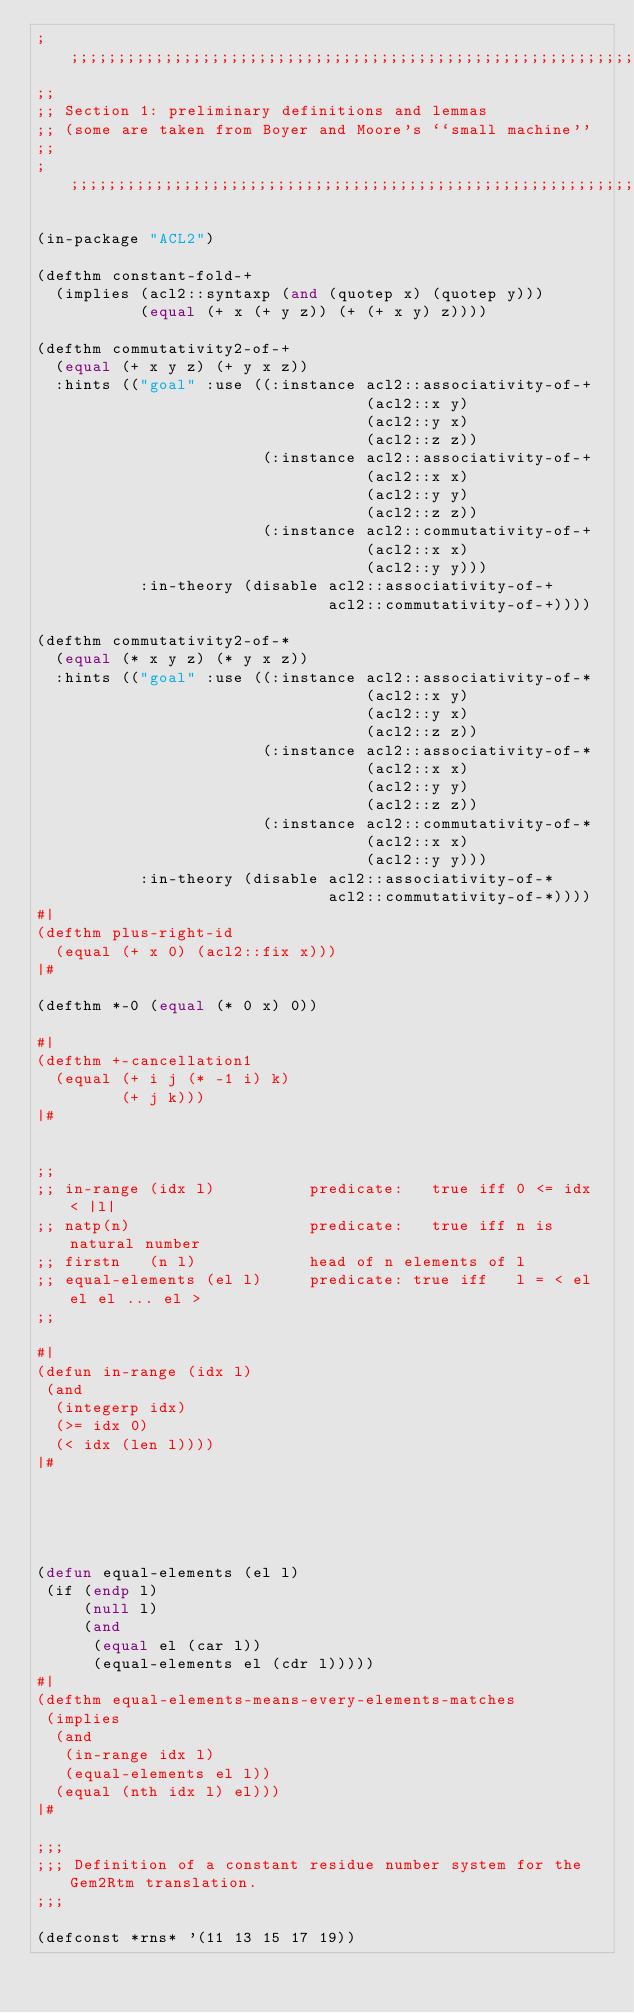<code> <loc_0><loc_0><loc_500><loc_500><_Lisp_>;;;;;;;;;;;;;;;;;;;;;;;;;;;;;;;;;;;;;;;;;;;;;;;;;;;;;;;;;;;;;;;;;;;;;;;;;
;;
;; Section 1: preliminary definitions and lemmas 
;; (some are taken from Boyer and Moore's ``small machine''
;;
;;;;;;;;;;;;;;;;;;;;;;;;;;;;;;;;;;;;;;;;;;;;;;;;;;;;;;;;;;;;;;;;;;;;;;;;;

(in-package "ACL2")

(defthm constant-fold-+
  (implies (acl2::syntaxp (and (quotep x) (quotep y)))
           (equal (+ x (+ y z)) (+ (+ x y) z))))

(defthm commutativity2-of-+
  (equal (+ x y z) (+ y x z))
  :hints (("goal" :use ((:instance acl2::associativity-of-+
                                   (acl2::x y)
                                   (acl2::y x)
                                   (acl2::z z))
                        (:instance acl2::associativity-of-+
                                   (acl2::x x)
                                   (acl2::y y)
                                   (acl2::z z))
                        (:instance acl2::commutativity-of-+
                                   (acl2::x x)
                                   (acl2::y y)))
           :in-theory (disable acl2::associativity-of-+
                               acl2::commutativity-of-+))))

(defthm commutativity2-of-*
  (equal (* x y z) (* y x z))
  :hints (("goal" :use ((:instance acl2::associativity-of-*
                                   (acl2::x y)
                                   (acl2::y x)
                                   (acl2::z z))
                        (:instance acl2::associativity-of-*
                                   (acl2::x x)
                                   (acl2::y y)
                                   (acl2::z z))
                        (:instance acl2::commutativity-of-*
                                   (acl2::x x)
                                   (acl2::y y)))
           :in-theory (disable acl2::associativity-of-*
                               acl2::commutativity-of-*))))
#|
(defthm plus-right-id
  (equal (+ x 0) (acl2::fix x)))
|#

(defthm *-0 (equal (* 0 x) 0))

#|
(defthm +-cancellation1
  (equal (+ i j (* -1 i) k)
         (+ j k)))
|#


;;
;; in-range (idx l)          predicate:   true iff 0 <= idx < |l|
;; natp(n)                   predicate:   true iff n is natural number
;; firstn   (n l)            head of n elements of l
;; equal-elements (el l)     predicate: true iff   l = < el el el ... el >
;; 

#|
(defun in-range (idx l)
 (and
  (integerp idx)
  (>= idx 0)
  (< idx (len l))))
|#





(defun equal-elements (el l)
 (if (endp l)
     (null l)
     (and 
      (equal el (car l))
      (equal-elements el (cdr l)))))
#|
(defthm equal-elements-means-every-elements-matches
 (implies
  (and
   (in-range idx l)
   (equal-elements el l))
  (equal (nth idx l) el)))
|#

;;; 
;;; Definition of a constant residue number system for the Gem2Rtm translation.
;;;

(defconst *rns* '(11 13 15 17 19))



</code> 